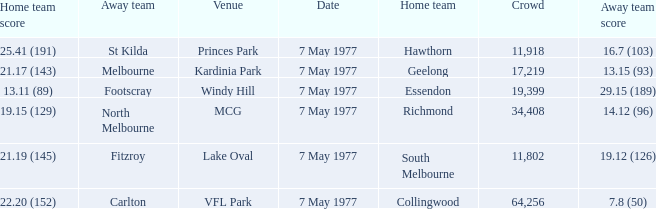Name the home team score for larger crowd than 11,918 for windy hill venue 13.11 (89). 